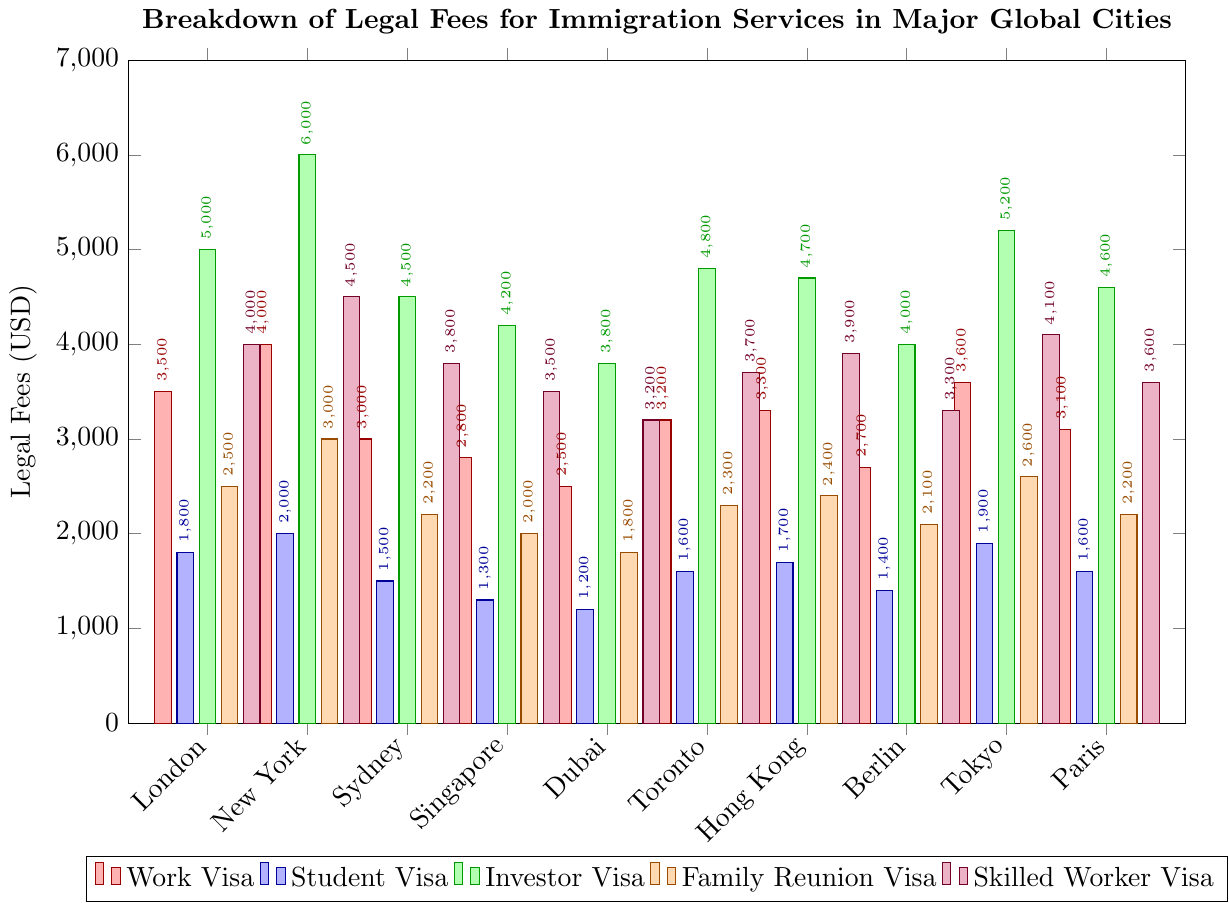Which city has the highest legal fee for a Work Visa? Look for the tallest bar in the "Work Visa" category which is red. The highest bar belongs to New York.
Answer: New York Which visa type generally has the lowest legal fees across all cities? Compare the height of the bars for each visa type across all cities. The shortest bars overall belong to the "Student Visa" category, which is blue.
Answer: Student Visa What is the total cost for an Investor Visa in Tokyo and Sydney combined? Identify the bars for the Investor Visa (green) in Tokyo and Sydney. The costs are 5200 and 4500, respectively. Add them together: 5200 + 4500 = 9700.
Answer: 9700 Which city has the lowest legal fee for a Family Reunion Visa? Look for the shortest bar in the "Family Reunion Visa" category which is orange. The shortest bar belongs to Dubai.
Answer: Dubai How much more expensive is the Skilled Worker Visa in New York compared to Dubai? Identify the bars for the Skilled Worker Visa (purple) in New York and Dubai. The costs are 4500 and 3200, respectively. Subtract the lesser amount from the greater amount: 4500 - 3200 = 1300.
Answer: 1300 What is the average cost for a Student Visa across all cities? Sum up the costs for the Student Visa (blue) across all cities and divide by the number of cities: (1800 + 2000 + 1500 + 1300 + 1200 + 1600 + 1700 + 1400 + 1900 + 1600) / 10 = 1600.
Answer: 1600 Which city has the highest overall average cost for all visa types? Calculate the average cost for all visa types for each city and compare. New York has the highest total (4000 + 2000 + 6000 + 3000 + 4500 = 19500) divided by 5 visa types: 19500 / 5 = 3900.
Answer: New York Which city has more expensive legal fees for a Work Visa, Paris or Berlin? Compare the bars for the Work Visa (red) in Paris and Berlin. Paris has 3100, Berlin has 2700. Therefore, Paris is more expensive.
Answer: Paris What is the difference in legal fees for an Investor Visa between the most and least expensive cities? Identify the highest and lowest bars in the Investor Visa category (green). The highest is Tokyo (5200) and the lowest is Dubai (3800). Subtract the lesser amount from the greater amount: 5200 - 3800 = 1400.
Answer: 1400 Across all cities, which visa type has the most significant variance in legal fees? Observe the spread and differences in bar heights for each visa type. The Investor Visa (green) shows the most variance, with fees ranging from 3800 to 6000.
Answer: Investor Visa 